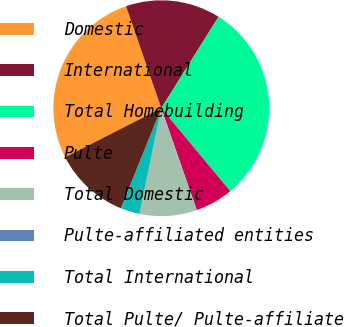Convert chart to OTSL. <chart><loc_0><loc_0><loc_500><loc_500><pie_chart><fcel>Domestic<fcel>International<fcel>Total Homebuilding<fcel>Pulte<fcel>Total Domestic<fcel>Pulte-affiliated entities<fcel>Total International<fcel>Total Pulte/ Pulte-affiliate<nl><fcel>27.22%<fcel>14.2%<fcel>30.06%<fcel>5.7%<fcel>8.54%<fcel>0.04%<fcel>2.87%<fcel>11.37%<nl></chart> 